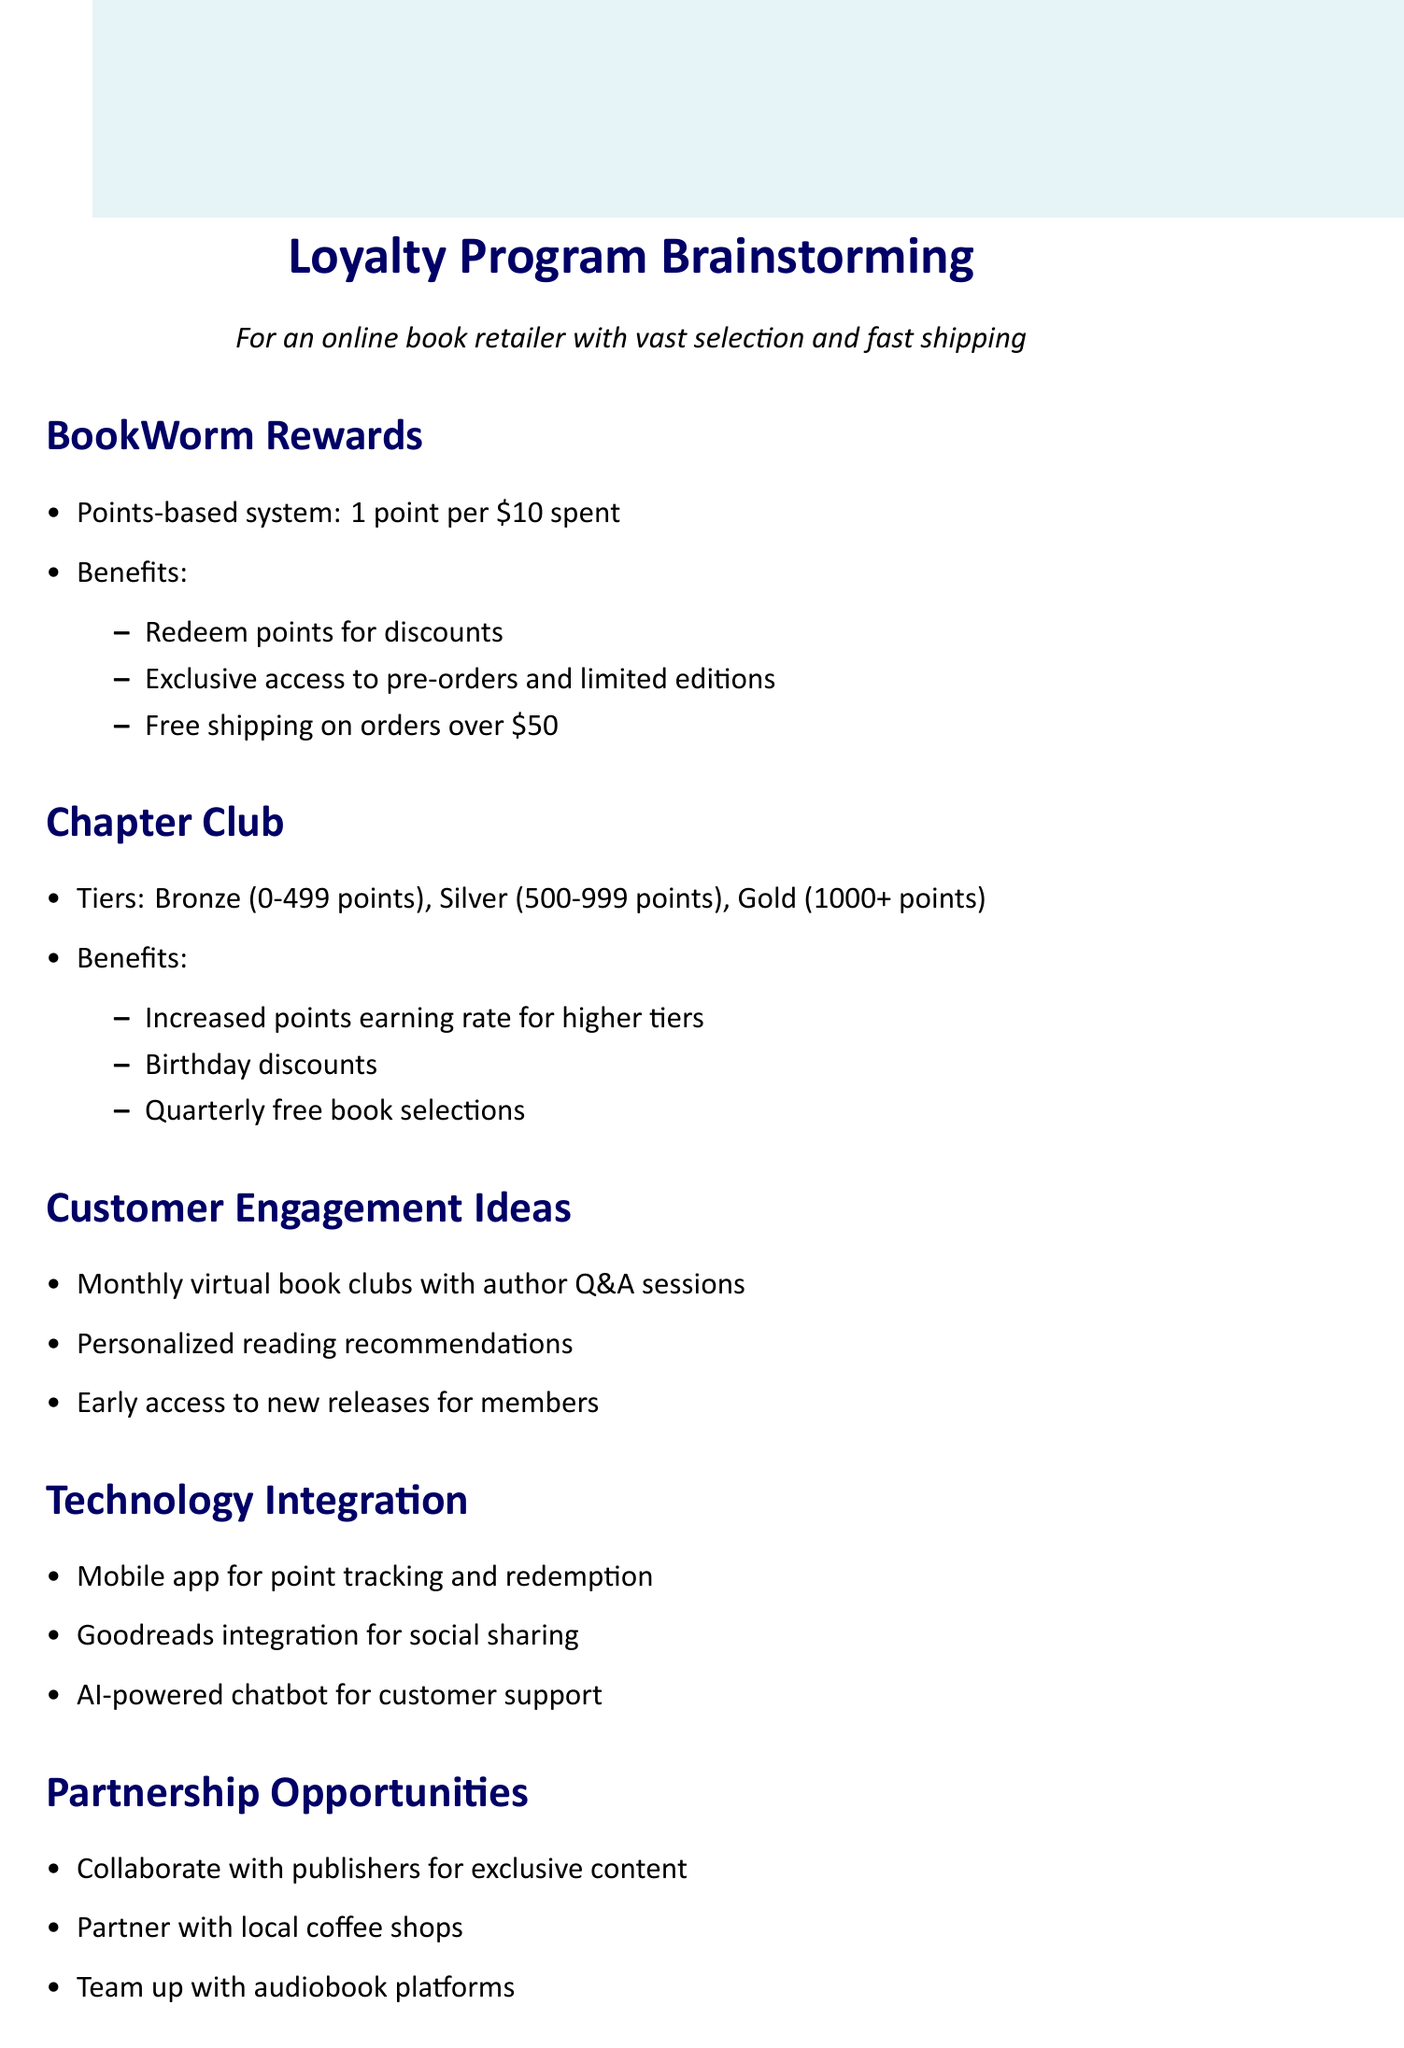What is the name of the first loyalty program? The document lists "BookWorm Rewards" as the name of the first loyalty program.
Answer: BookWorm Rewards How many points do customers earn for every $10 spent in the BookWorm Rewards program? The document states that customers earn 1 point for every $10 spent in the BookWorm Rewards program.
Answer: 1 point What benefit do Gold tier members in the Chapter Club receive? The document states that Gold tier members receive an increased points earning rate for higher tiers, indicating a benefit tied to their tier status.
Answer: Increased points earning rate What is one way to enhance customer engagement mentioned in the document? The document lists "Monthly virtual book clubs with author Q&A sessions" as a customer engagement idea.
Answer: Monthly virtual book clubs Which technology integration allows customers to track their points? The document specifies a "Mobile app for easy point tracking and redemption" as a technology integration feature.
Answer: Mobile app What is one partnership opportunity mentioned in the document? "Collaborate with publishers for exclusive content and signed copies" is one of the partnership opportunities listed.
Answer: Collaborate with publishers How can the data be utilized according to the document? The document mentions analyzing customer reading preferences for targeted promotions as a way data can be utilized.
Answer: Analyze reading preferences What tier is associated with 500-999 points in the Chapter Club? The document clearly states that the tier associated with 500-999 points is Silver.
Answer: Silver What is one benefit of the loyalty program that includes quarterly free book selections? The document mentions that quarterly free book selections are a benefit for Chapter Club members.
Answer: Quarterly free book selections 